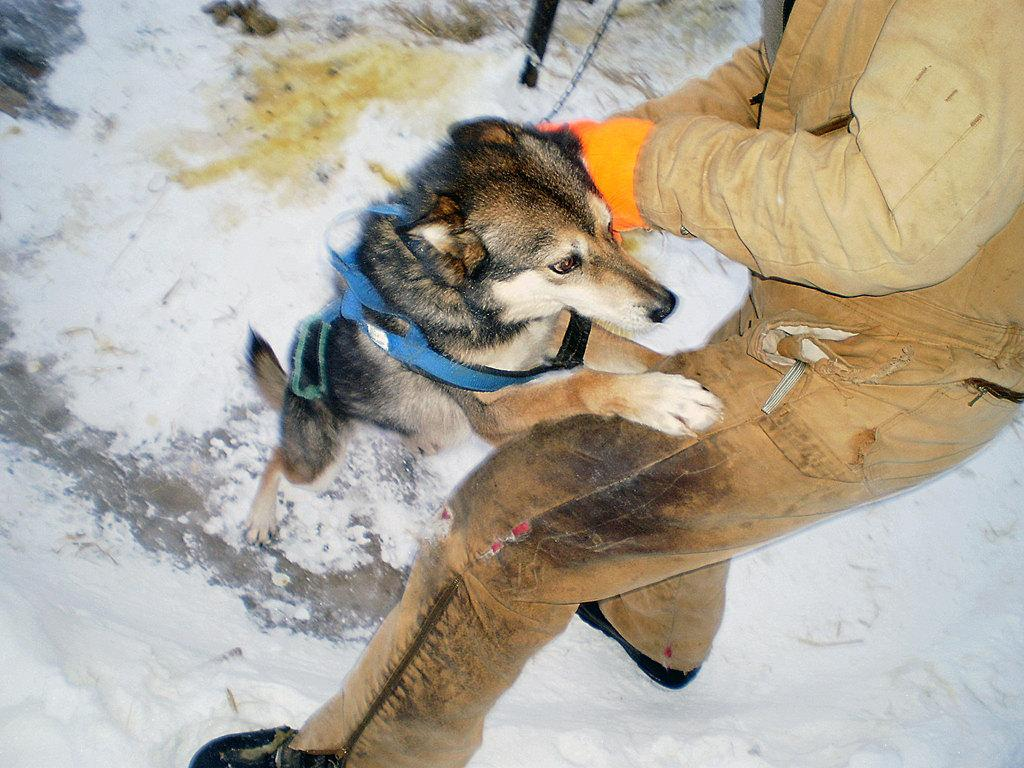What type of animal is in the image? There is a dog in the image. Who or what else is present in the image? There is a person in the image. What is the setting of the image? The image consists of snow. What is at the top of the image? There is a pole at the top of the image. What is connected to the pole? There is a chain associated with the pole. What type of food is being served to the passengers in the image? There are no passengers or food present in the image. 